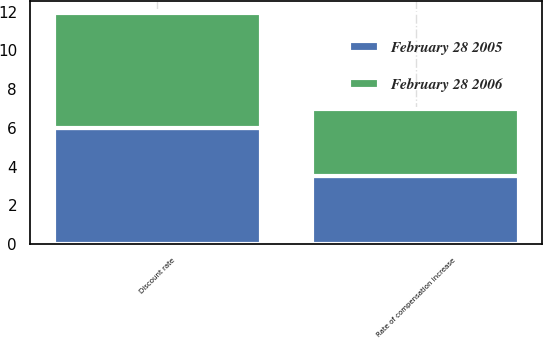<chart> <loc_0><loc_0><loc_500><loc_500><stacked_bar_chart><ecel><fcel>Discount rate<fcel>Rate of compensation increase<nl><fcel>February 28 2006<fcel>5.95<fcel>3.5<nl><fcel>February 28 2005<fcel>6<fcel>3.5<nl></chart> 